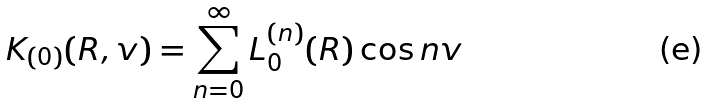<formula> <loc_0><loc_0><loc_500><loc_500>K _ { ( 0 ) } ( R , v ) = \sum _ { n = 0 } ^ { \infty } L _ { 0 } ^ { ( n ) } ( R ) \cos n v</formula> 